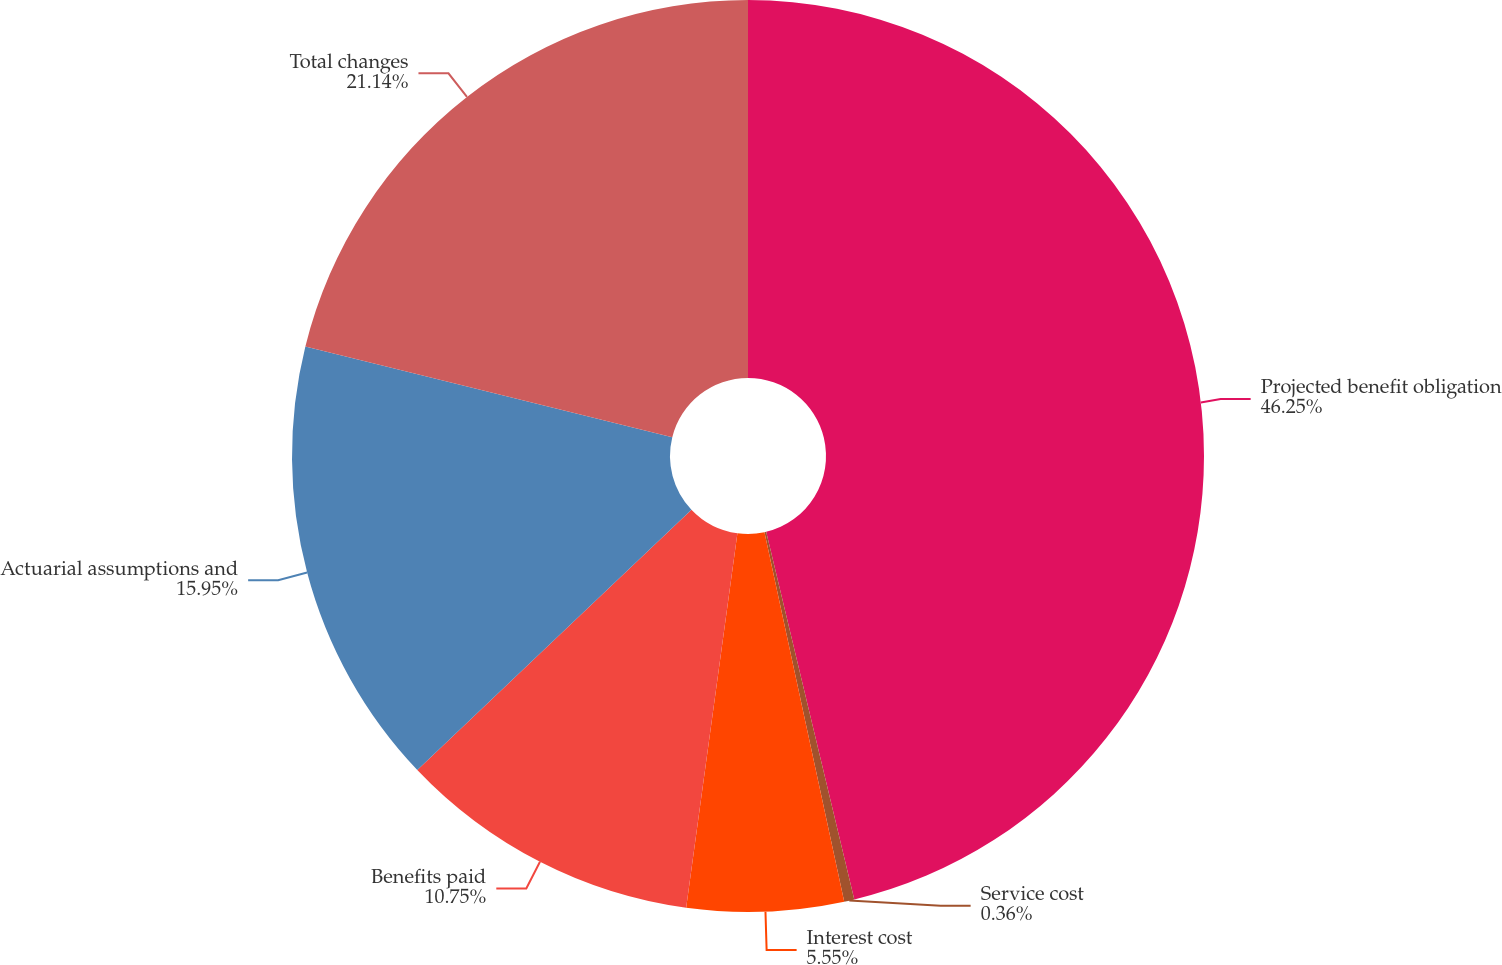Convert chart to OTSL. <chart><loc_0><loc_0><loc_500><loc_500><pie_chart><fcel>Projected benefit obligation<fcel>Service cost<fcel>Interest cost<fcel>Benefits paid<fcel>Actuarial assumptions and<fcel>Total changes<nl><fcel>46.26%<fcel>0.36%<fcel>5.55%<fcel>10.75%<fcel>15.95%<fcel>21.14%<nl></chart> 